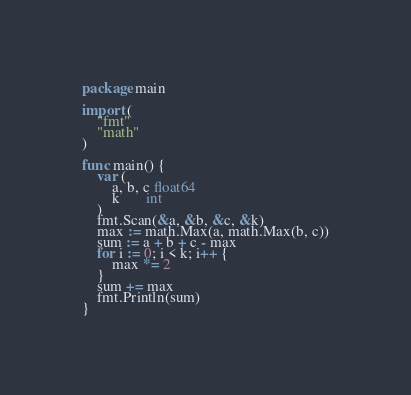<code> <loc_0><loc_0><loc_500><loc_500><_Go_>package main

import (
	"fmt"
	"math"
)

func main() {
	var (
		a, b, c float64
		k       int
	)
	fmt.Scan(&a, &b, &c, &k)
	max := math.Max(a, math.Max(b, c))
	sum := a + b + c - max
	for i := 0; i < k; i++ {
		max *= 2
	}
	sum += max
	fmt.Println(sum)
}
</code> 